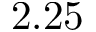<formula> <loc_0><loc_0><loc_500><loc_500>2 . 2 5</formula> 